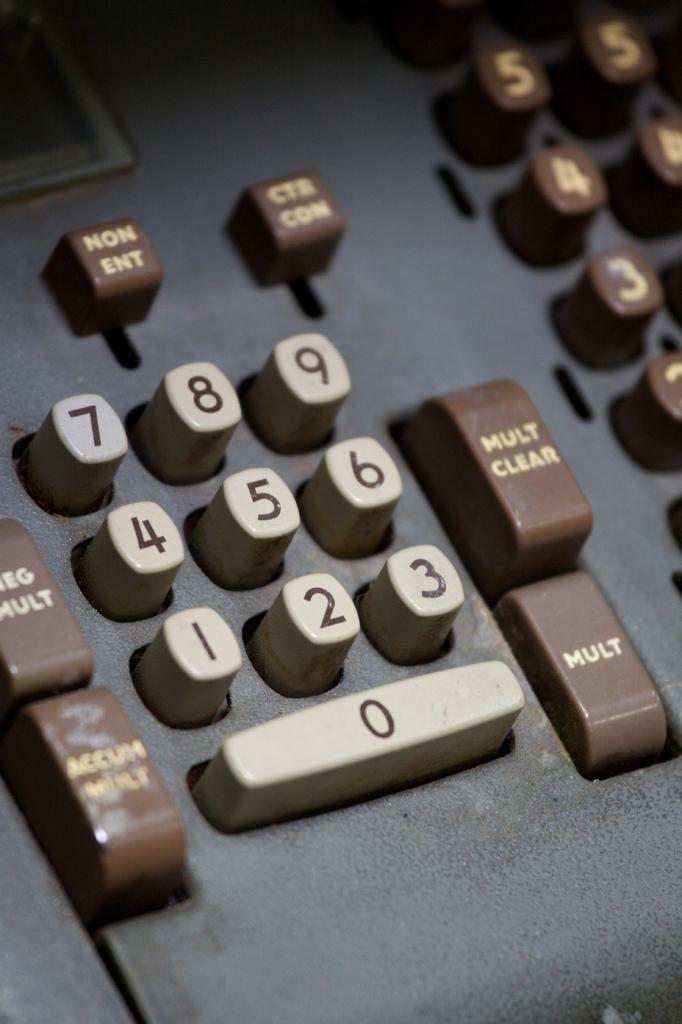<image>
Summarize the visual content of the image. A keyboard like on an old adding machine with numbered keys and mult keys. 